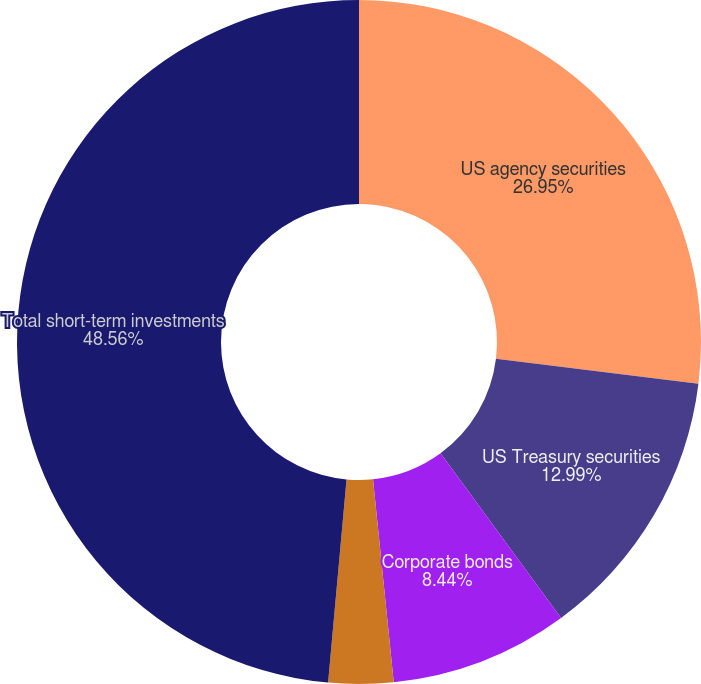<chart> <loc_0><loc_0><loc_500><loc_500><pie_chart><fcel>US agency securities<fcel>US Treasury securities<fcel>Corporate bonds<fcel>Asset-backed and other debt<fcel>Total short-term investments<nl><fcel>26.95%<fcel>12.99%<fcel>8.44%<fcel>3.06%<fcel>48.56%<nl></chart> 